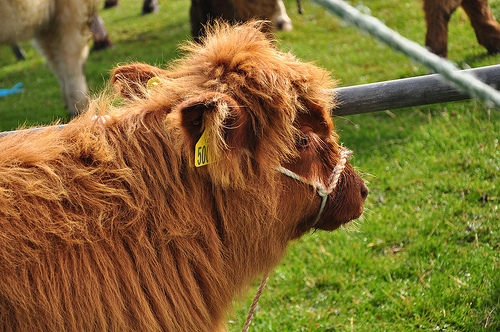<image>
Can you confirm if the cow is behind the fence? No. The cow is not behind the fence. From this viewpoint, the cow appears to be positioned elsewhere in the scene. 